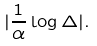Convert formula to latex. <formula><loc_0><loc_0><loc_500><loc_500>| \frac { 1 } { \alpha } \log \Delta | .</formula> 